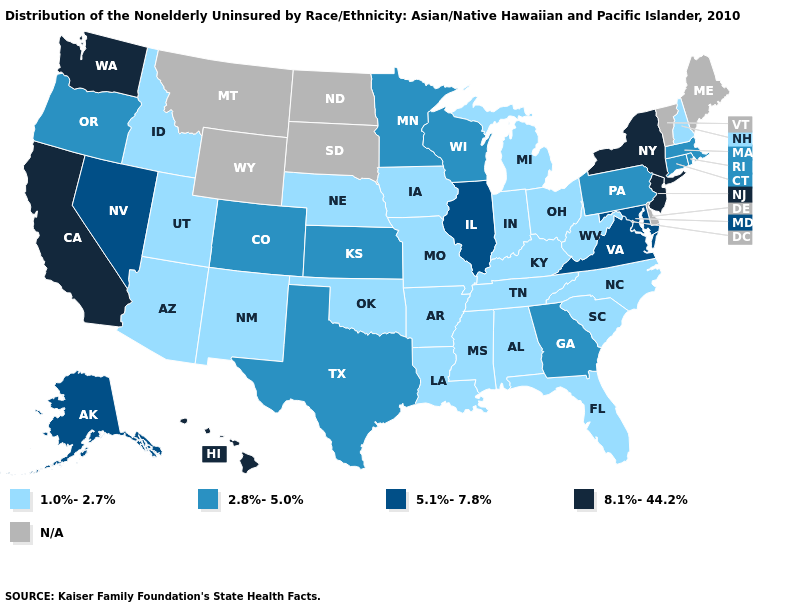Which states have the lowest value in the Northeast?
Short answer required. New Hampshire. How many symbols are there in the legend?
Keep it brief. 5. Name the states that have a value in the range N/A?
Keep it brief. Delaware, Maine, Montana, North Dakota, South Dakota, Vermont, Wyoming. Is the legend a continuous bar?
Give a very brief answer. No. Among the states that border Idaho , which have the lowest value?
Keep it brief. Utah. Does the map have missing data?
Answer briefly. Yes. Among the states that border Kentucky , which have the highest value?
Write a very short answer. Illinois, Virginia. Name the states that have a value in the range 2.8%-5.0%?
Write a very short answer. Colorado, Connecticut, Georgia, Kansas, Massachusetts, Minnesota, Oregon, Pennsylvania, Rhode Island, Texas, Wisconsin. Which states have the lowest value in the USA?
Short answer required. Alabama, Arizona, Arkansas, Florida, Idaho, Indiana, Iowa, Kentucky, Louisiana, Michigan, Mississippi, Missouri, Nebraska, New Hampshire, New Mexico, North Carolina, Ohio, Oklahoma, South Carolina, Tennessee, Utah, West Virginia. What is the value of Kansas?
Quick response, please. 2.8%-5.0%. Name the states that have a value in the range 2.8%-5.0%?
Give a very brief answer. Colorado, Connecticut, Georgia, Kansas, Massachusetts, Minnesota, Oregon, Pennsylvania, Rhode Island, Texas, Wisconsin. Name the states that have a value in the range 1.0%-2.7%?
Short answer required. Alabama, Arizona, Arkansas, Florida, Idaho, Indiana, Iowa, Kentucky, Louisiana, Michigan, Mississippi, Missouri, Nebraska, New Hampshire, New Mexico, North Carolina, Ohio, Oklahoma, South Carolina, Tennessee, Utah, West Virginia. Among the states that border Arizona , does New Mexico have the lowest value?
Short answer required. Yes. Among the states that border Minnesota , which have the highest value?
Keep it brief. Wisconsin. What is the highest value in the South ?
Keep it brief. 5.1%-7.8%. 